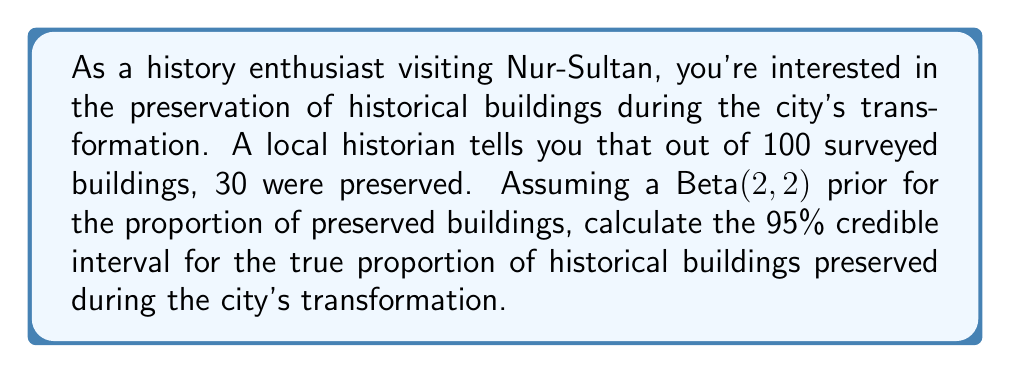Give your solution to this math problem. To solve this problem, we'll use Bayesian inference with a Beta prior and Binomial likelihood. The steps are as follows:

1) Prior: Beta(α, β) = Beta(2, 2)
2) Data: 30 successes out of 100 trials
3) Posterior: Beta(α + successes, β + failures) = Beta(2 + 30, 2 + 70) = Beta(32, 72)

To find the 95% credible interval, we need to calculate the 2.5th and 97.5th percentiles of this Beta(32, 72) distribution.

The probability density function of the Beta distribution is:

$$ f(x; \alpha, \beta) = \frac{x^{\alpha-1}(1-x)^{\beta-1}}{B(\alpha, \beta)} $$

Where B(α, β) is the Beta function.

To find the credible interval, we need to solve:

$$ \int_0^{l} f(x; 32, 72) dx = 0.025 $$
$$ \int_0^{u} f(x; 32, 72) dx = 0.975 $$

Where l and u are the lower and upper bounds of the credible interval.

These integrals don't have closed-form solutions, so we typically use statistical software or numerical methods to solve them. Using such methods, we find:

Lower bound (l) ≈ 0.2229
Upper bound (u) ≈ 0.3831

Therefore, the 95% credible interval is approximately (0.2229, 0.3831).
Answer: The 95% credible interval for the proportion of historical buildings preserved during Nur-Sultan's transformation is approximately (0.2229, 0.3831). 